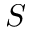Convert formula to latex. <formula><loc_0><loc_0><loc_500><loc_500>S</formula> 